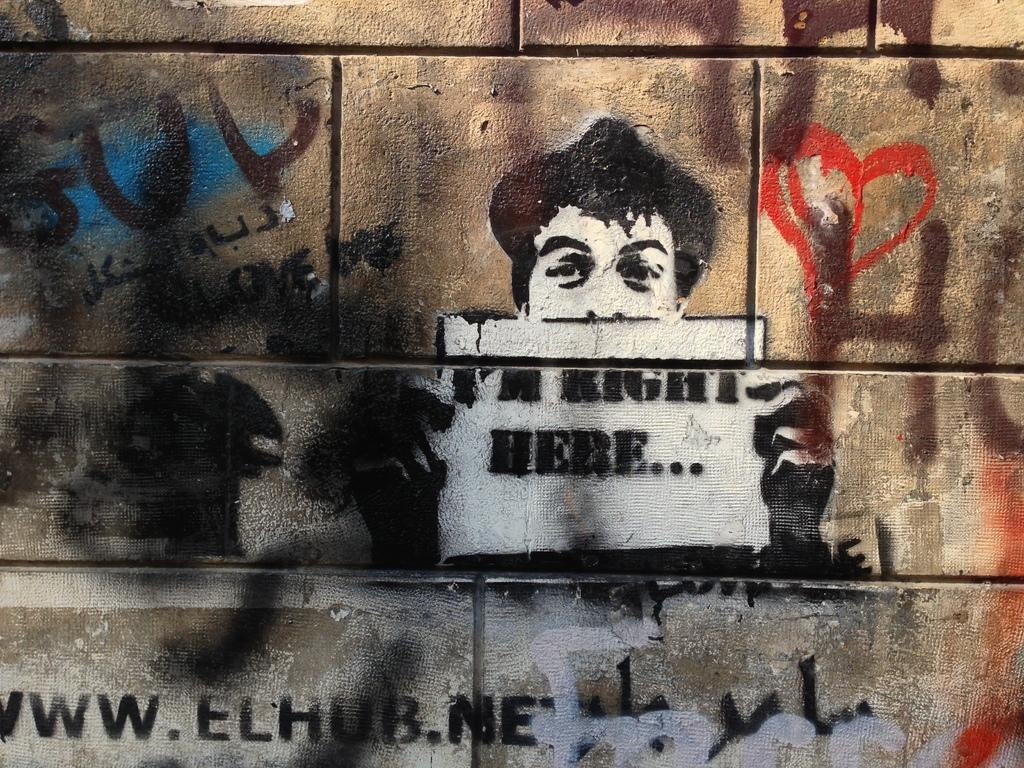What can be seen on the wall in the image? There are drawings and texts written on the wall. Can you describe the drawings on the wall? Unfortunately, the details of the drawings cannot be determined from the provided facts. What do the texts on the wall say? The specific content of the texts on the wall cannot be determined from the provided facts. How many times does the number 7 appear in the image? There is no mention of the number 7 or any numbers in the provided facts, so it cannot be determined from the image. 